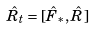Convert formula to latex. <formula><loc_0><loc_0><loc_500><loc_500>\hat { R } _ { t } = [ \hat { F } _ { * } , \hat { R } ]</formula> 